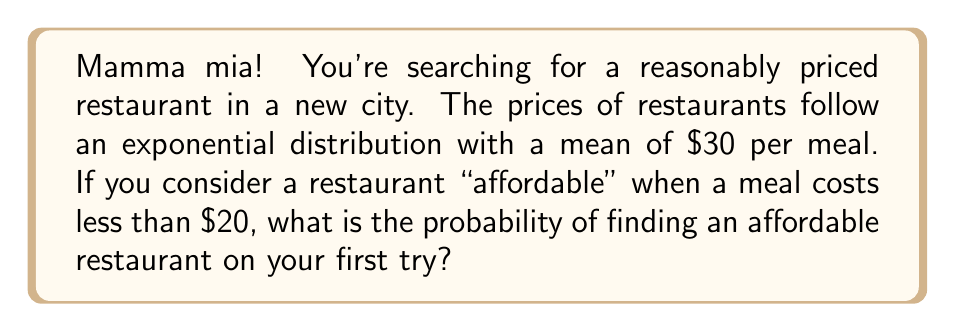Provide a solution to this math problem. Let's approach this step-by-step:

1) The exponential distribution has a probability density function:
   $$f(x) = \lambda e^{-\lambda x}$$
   where $\lambda$ is the rate parameter.

2) We're given that the mean is $30. For an exponential distribution, the mean is $\frac{1}{\lambda}$. So:
   $$\frac{1}{\lambda} = 30$$
   $$\lambda = \frac{1}{30}$$

3) We want to find $P(X < 20)$, where $X$ is the price of a meal.

4) For an exponential distribution, the cumulative distribution function is:
   $$F(x) = 1 - e^{-\lambda x}$$

5) Therefore:
   $$P(X < 20) = 1 - e^{-\frac{1}{30} \cdot 20}$$

6) Let's calculate:
   $$P(X < 20) = 1 - e^{-\frac{2}{3}}$$
   $$= 1 - (e^{-1})^{\frac{2}{3}}$$
   $$\approx 1 - 0.5134$$
   $$\approx 0.4866$$

7) Converting to a percentage:
   $$0.4866 \cdot 100\% \approx 48.66\%$$
Answer: 48.66% 